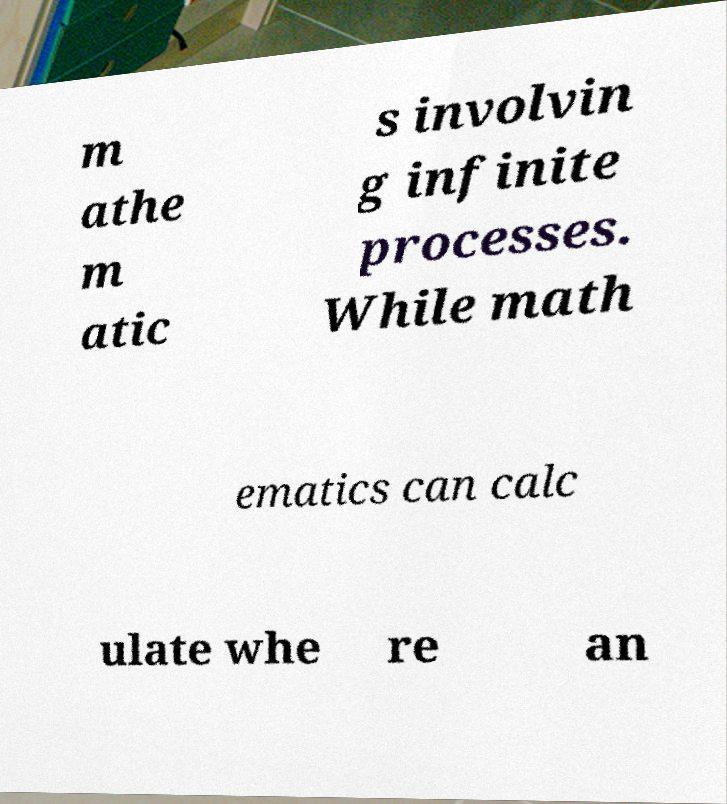For documentation purposes, I need the text within this image transcribed. Could you provide that? m athe m atic s involvin g infinite processes. While math ematics can calc ulate whe re an 